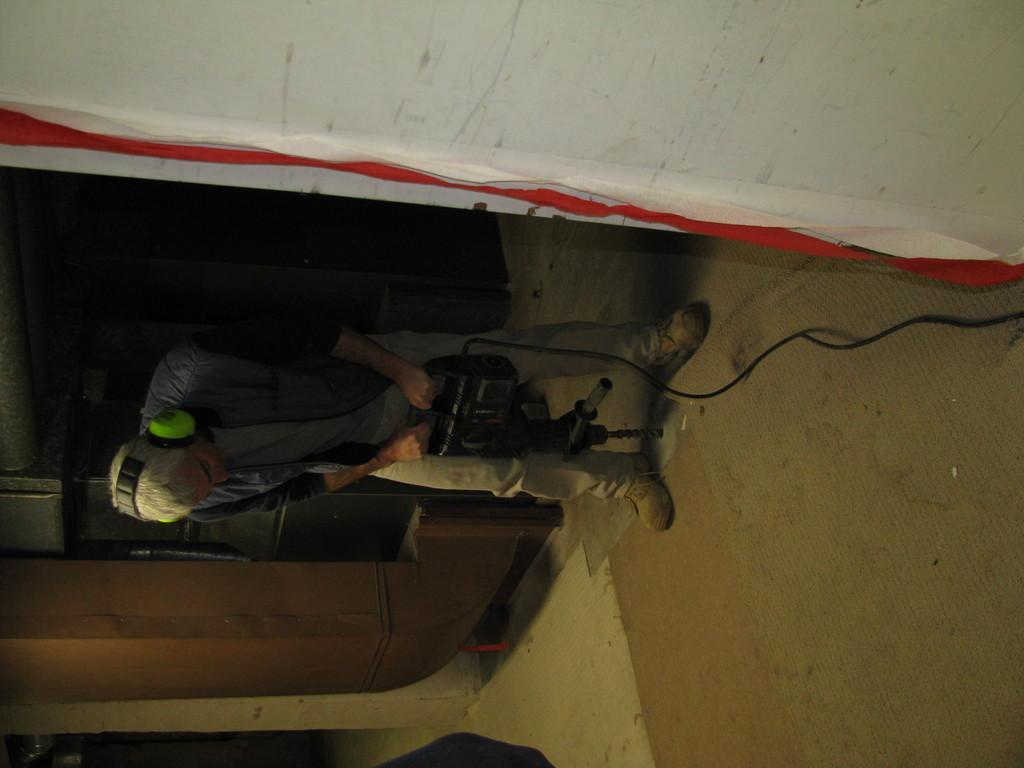What is the man in the image doing? The man is drilling the floor in the image. Where is the man located? The man is inside a room. What is the man wearing on his head? The man is wearing a headset. What type of clothing is the man wearing on his upper body? The man is wearing a jacket. What type of copper material can be seen in the image? There is no copper material present in the image. How does the man's drilling compare to a similar task performed by a woman? The image does not include a woman performing a similar task, so a comparison cannot be made. 